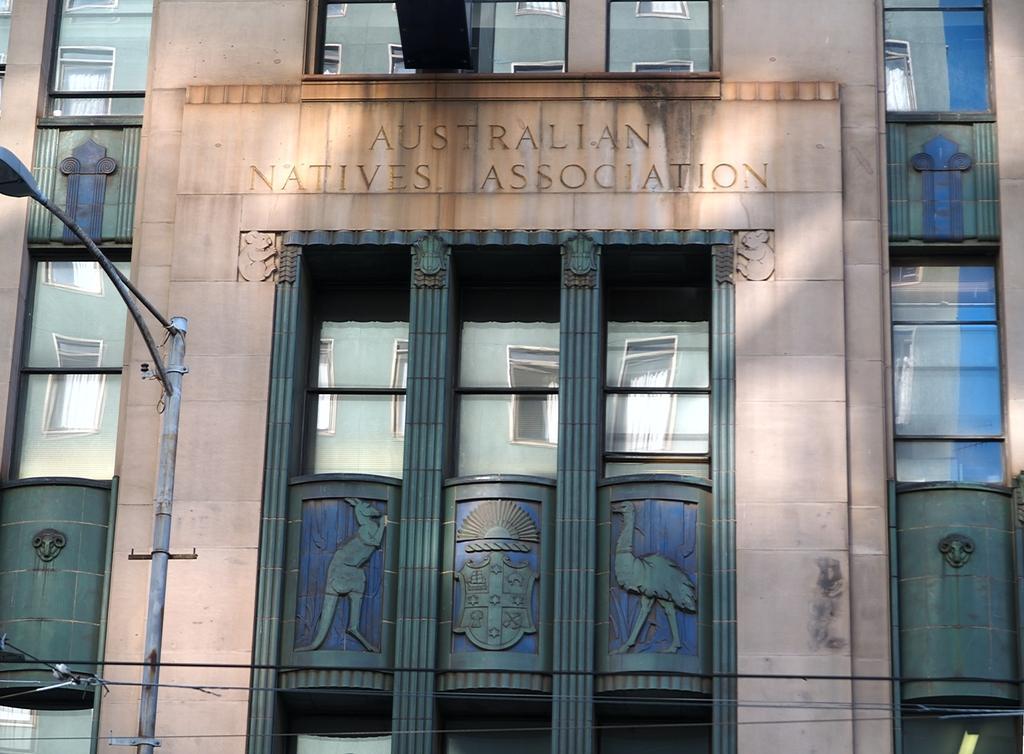What type of structure is present in the image? There is a building in the image. What feature can be seen on the building? The building has windows. What other object is located near the building? There is a light pole near the building. Where is the crib located in the image? There is no crib present in the image. What type of dirt can be seen on the plate in the image? There is no plate or dirt present in the image. 